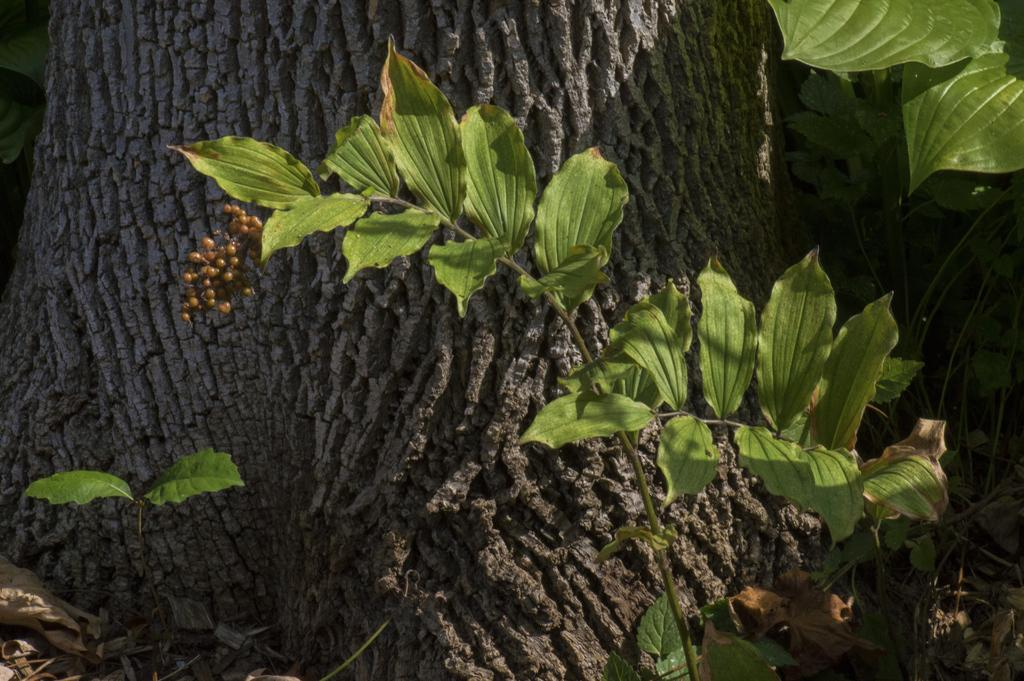What is present in the image? There is a plant in the image. What can be seen attached to the plant? There are things attached to the plant. What can be seen in the background of the image? There is a tree trunk visible in the background of the image. What is the title of the book held by the person in the image? There is no person or book present in the image; it only features a plant with things attached to it and a tree trunk in the background. 